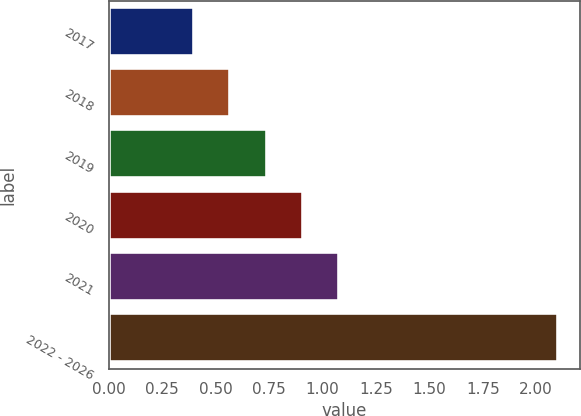Convert chart to OTSL. <chart><loc_0><loc_0><loc_500><loc_500><bar_chart><fcel>2017<fcel>2018<fcel>2019<fcel>2020<fcel>2021<fcel>2022 - 2026<nl><fcel>0.4<fcel>0.57<fcel>0.74<fcel>0.91<fcel>1.08<fcel>2.1<nl></chart> 